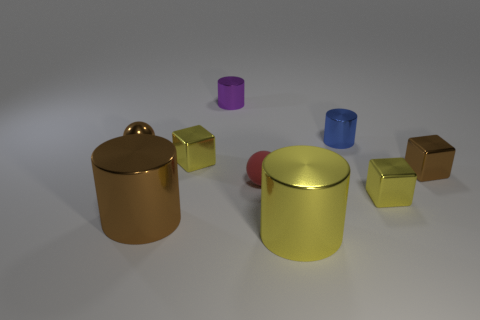Can you describe the atmosphere suggested by this image? The image conveys a minimalistic and serene atmosphere, likely set indoors. The varied sizes of objects and their reflective materials lend a sense of abstractness and modernity. The arrangement appears intentional but not functional, hinting at an artistic or illustrative purpose rather than a practical one. 